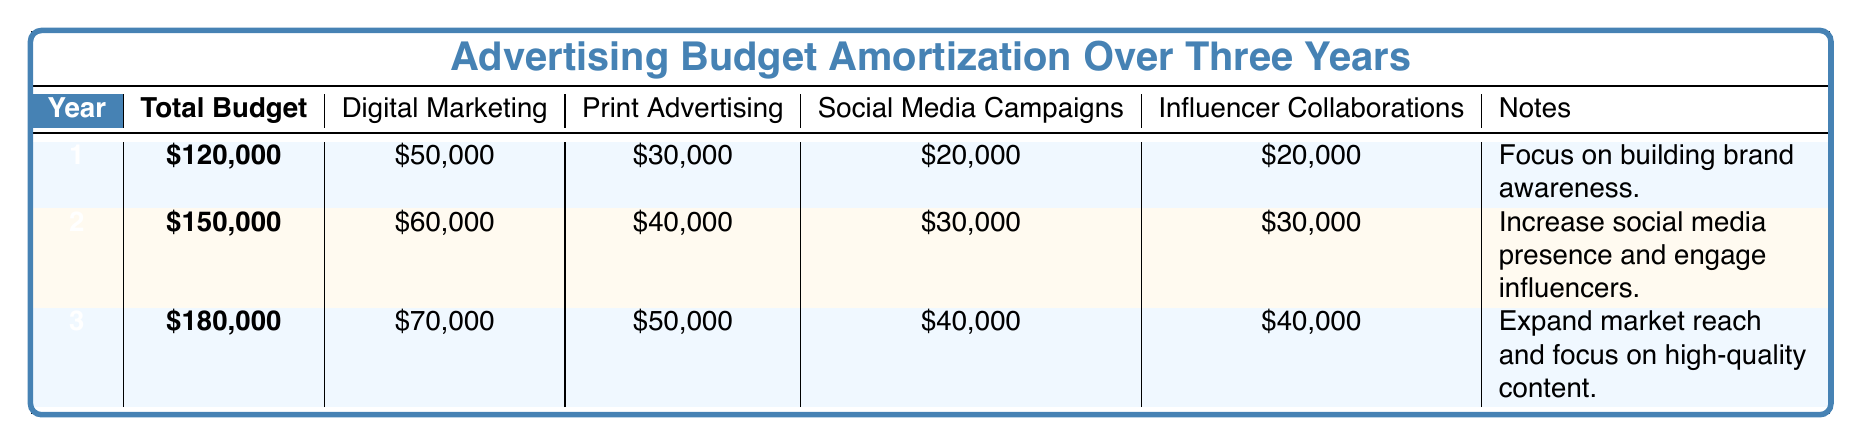What is the total budget for year 2? The total budget for year 2 is directly listed in the table under the total budget column for that year. It shows 150,000.
Answer: 150,000 What is the allocation for social media campaigns in the first year? The table provides a specific allocation of budget for social media campaigns directly under year 1, which is 20,000.
Answer: 20,000 Which year has the highest total budget? By comparing the total budget values across the three years, the highest total budget is noted in year 3, where it amounts to 180,000.
Answer: Year 3 What is the total amount allocated to influencer collaborations over the three years? The allocations for influencer collaborations across the three years are: year 1 has 20,000, year 2 has 30,000, and year 3 has 40,000. Adding these gives 20,000 + 30,000 + 40,000 = 90,000.
Answer: 90,000 Is the budget for digital marketing increasing each year? By looking at the digital marketing budget allocations for each year, they are 50,000 for year 1, 60,000 for year 2, and 70,000 for year 3. Since these values are progressively higher, the budget is indeed increasing.
Answer: Yes What is the average allocation for print advertising over the three years? First, we gather print advertising allocations: year 1 - 30,000, year 2 - 40,000, year 3 - 50,000. Summing these gives 30,000 + 40,000 + 50,000 = 120,000. To find the average, we divide this total by 3, resulting in 120,000 / 3 = 40,000.
Answer: 40,000 Did year 1 allocate more to print advertising than to influencer collaborations? Looking at the allocations, year 1 allocated 30,000 to print advertising and 20,000 to influencer collaborations. Since 30,000 is greater than 20,000, year 1 did allocate more to print advertising.
Answer: Yes If you combine the budgets for social media campaigns and influencer collaborations for year 3, what is the total? The budget allocation for social media campaigns in year 3 is 40,000, and for influencer collaborations, it is 40,000 as well. Adding these amounts together gives 40,000 + 40,000 = 80,000.
Answer: 80,000 Which advertising category received the least budget allocation in year 2? In year 2, the allocations were 60,000 for digital marketing, 40,000 for print advertising, 30,000 for social media campaigns, and 30,000 for influencer collaborations. The category with the least amount is social media campaigns at 30,000.
Answer: Social media campaigns 